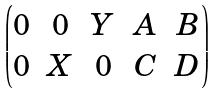<formula> <loc_0><loc_0><loc_500><loc_500>\begin{pmatrix} 0 & 0 & Y & A & B \\ 0 & X & 0 & C & D \end{pmatrix}</formula> 